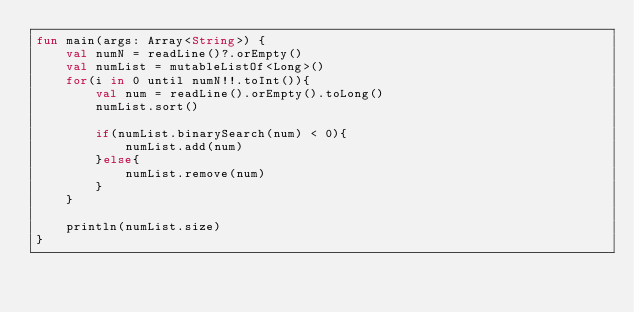<code> <loc_0><loc_0><loc_500><loc_500><_Kotlin_>fun main(args: Array<String>) {
    val numN = readLine()?.orEmpty()
    val numList = mutableListOf<Long>()
    for(i in 0 until numN!!.toInt()){
        val num = readLine().orEmpty().toLong()
        numList.sort()

        if(numList.binarySearch(num) < 0){
            numList.add(num)
        }else{
            numList.remove(num)
        }
    }

    println(numList.size)
}</code> 